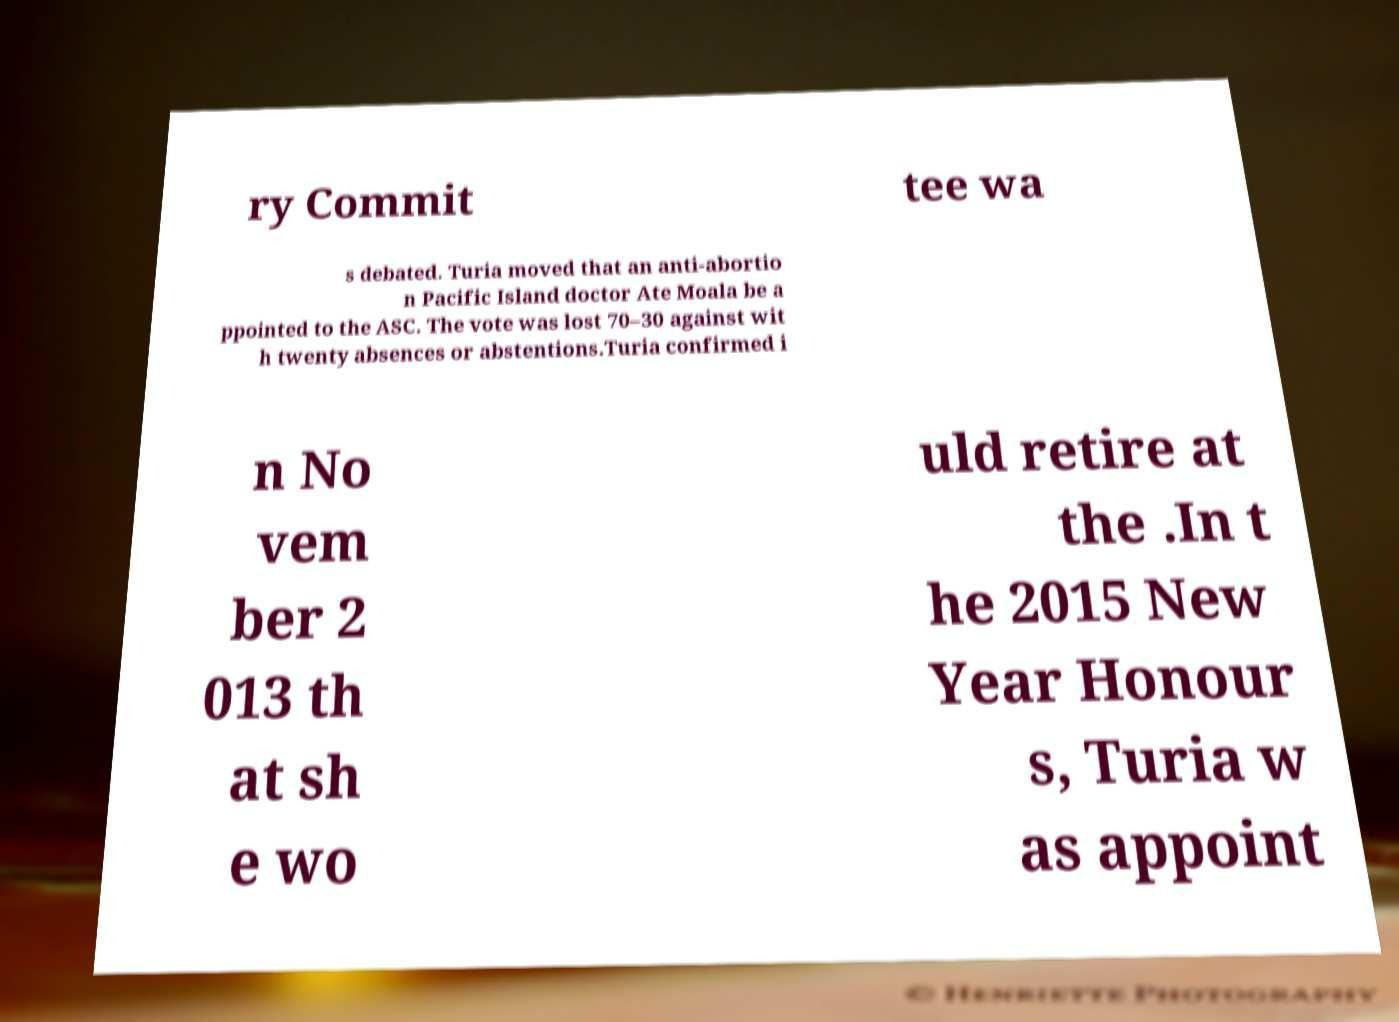I need the written content from this picture converted into text. Can you do that? ry Commit tee wa s debated. Turia moved that an anti-abortio n Pacific Island doctor Ate Moala be a ppointed to the ASC. The vote was lost 70–30 against wit h twenty absences or abstentions.Turia confirmed i n No vem ber 2 013 th at sh e wo uld retire at the .In t he 2015 New Year Honour s, Turia w as appoint 